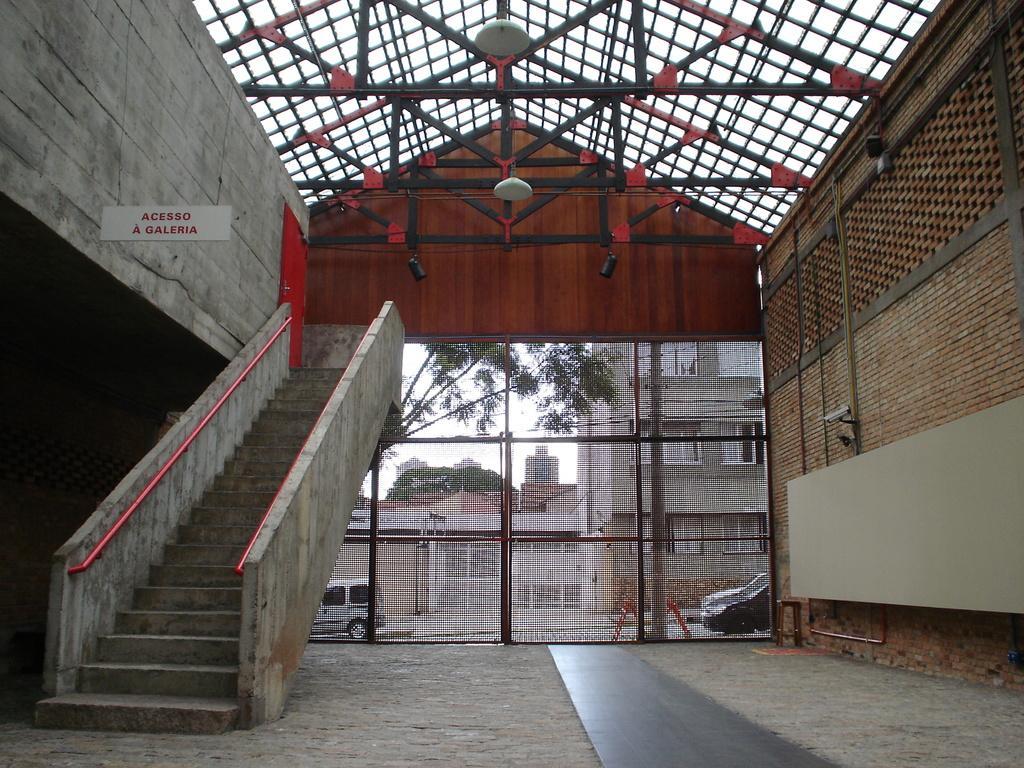How would you summarize this image in a sentence or two? This is a inside view of a building, where there are lights, CC camera , iron grills, door, staircase, name board hanging, and in the background there are buildings, trees, vehicles on the road, sky. 